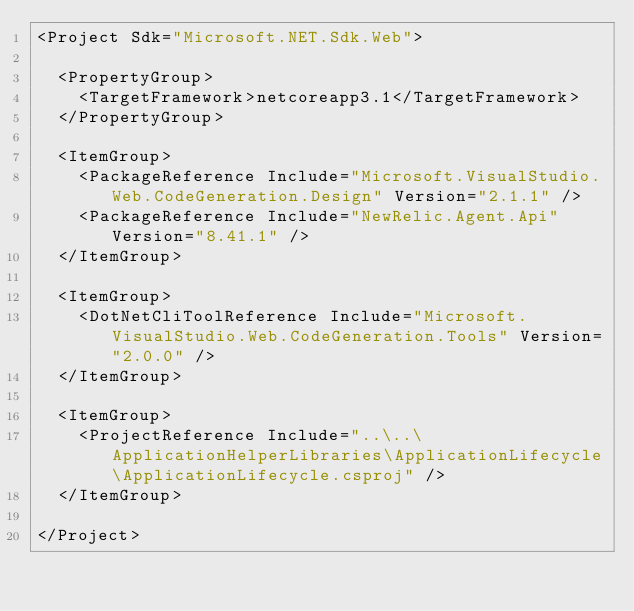Convert code to text. <code><loc_0><loc_0><loc_500><loc_500><_XML_><Project Sdk="Microsoft.NET.Sdk.Web">

  <PropertyGroup>
    <TargetFramework>netcoreapp3.1</TargetFramework>
  </PropertyGroup>

  <ItemGroup>
    <PackageReference Include="Microsoft.VisualStudio.Web.CodeGeneration.Design" Version="2.1.1" />
    <PackageReference Include="NewRelic.Agent.Api" Version="8.41.1" />
  </ItemGroup>

  <ItemGroup>
    <DotNetCliToolReference Include="Microsoft.VisualStudio.Web.CodeGeneration.Tools" Version="2.0.0" />
  </ItemGroup>

  <ItemGroup>
    <ProjectReference Include="..\..\ApplicationHelperLibraries\ApplicationLifecycle\ApplicationLifecycle.csproj" />
  </ItemGroup>

</Project>
</code> 